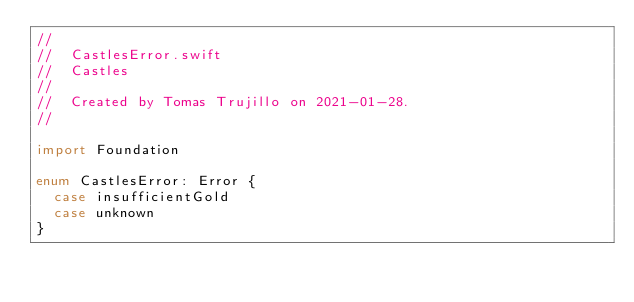Convert code to text. <code><loc_0><loc_0><loc_500><loc_500><_Swift_>//
//  CastlesError.swift
//  Castles
//
//  Created by Tomas Trujillo on 2021-01-28.
//

import Foundation

enum CastlesError: Error {
  case insufficientGold
  case unknown
}
</code> 